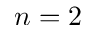Convert formula to latex. <formula><loc_0><loc_0><loc_500><loc_500>n = 2</formula> 